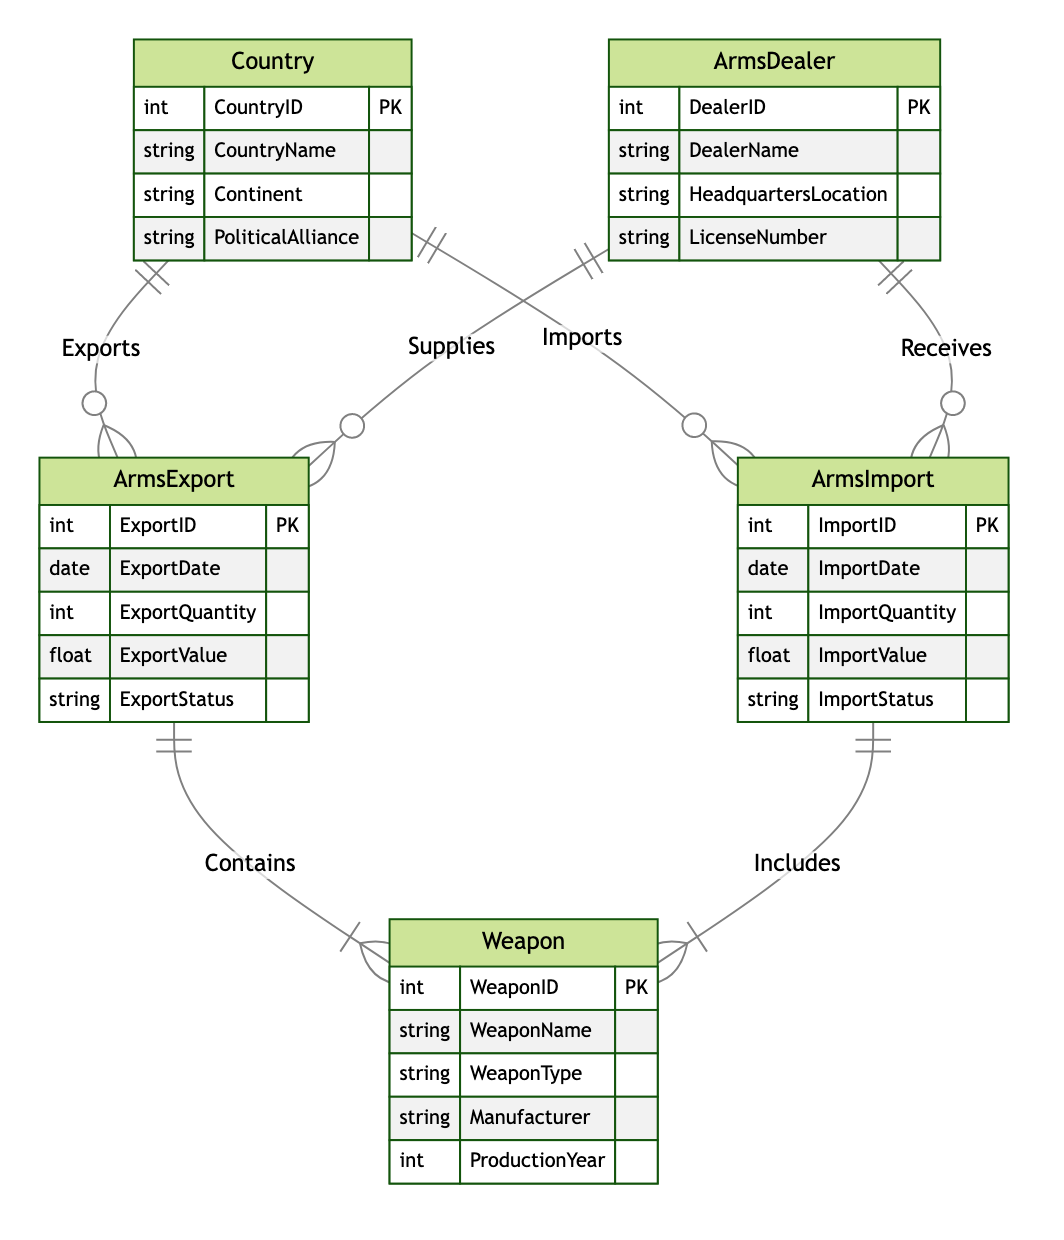What entities are included in the diagram? The diagram lists five entities: Country, ArmsDealer, ArmsExport, ArmsImport, and Weapon.
Answer: Country, ArmsDealer, ArmsExport, ArmsImport, Weapon How many primary keys are defined in the Country entity? The Country entity has one primary key, which is CountryID.
Answer: One Which entity is associated with the 'Exports' relationship? The 'Exports' relationship connects the Country entity to the ArmsExport entity.
Answer: ArmsExport What relationship connects ArmsDealer to ArmsImport? The relationship is called 'Receives.'
Answer: Receives How many relationships are depicted in the diagram? There are six relationships shown connecting different entities within the diagram.
Answer: Six Which entity is related to both ArmsExport and ArmsImport? The ArmsDealer entity is the one related to both ArmsExport and ArmsImport entities through Supplies and Receives relationships.
Answer: ArmsDealer What attributes are present in the Weapon entity? The attributes in the Weapon entity include WeaponID, WeaponName, WeaponType, Manufacturer, and ProductionYear.
Answer: WeaponID, WeaponName, WeaponType, Manufacturer, ProductionYear How is the 'Contains' relationship defined in the diagram? The 'Contains' relationship indicates that ArmsExport holds a connection to the Weapon entity.
Answer: ArmsExport Which entity represents the export activity? The entity representing export activity is ArmsExport.
Answer: ArmsExport Which attribute indicates the date of import in the ArmsImport entity? The attribute is ImportDate, which specifically records the date of import activities.
Answer: ImportDate 